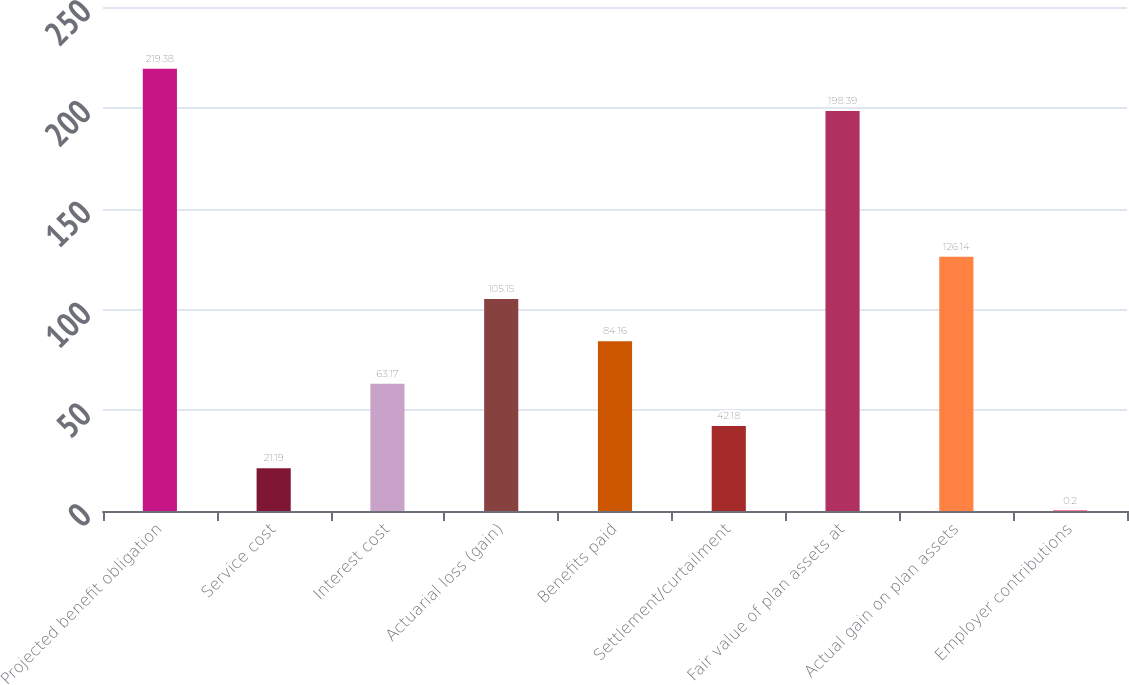Convert chart to OTSL. <chart><loc_0><loc_0><loc_500><loc_500><bar_chart><fcel>Projected benefit obligation<fcel>Service cost<fcel>Interest cost<fcel>Actuarial loss (gain)<fcel>Benefits paid<fcel>Settlement/curtailment<fcel>Fair value of plan assets at<fcel>Actual gain on plan assets<fcel>Employer contributions<nl><fcel>219.38<fcel>21.19<fcel>63.17<fcel>105.15<fcel>84.16<fcel>42.18<fcel>198.39<fcel>126.14<fcel>0.2<nl></chart> 